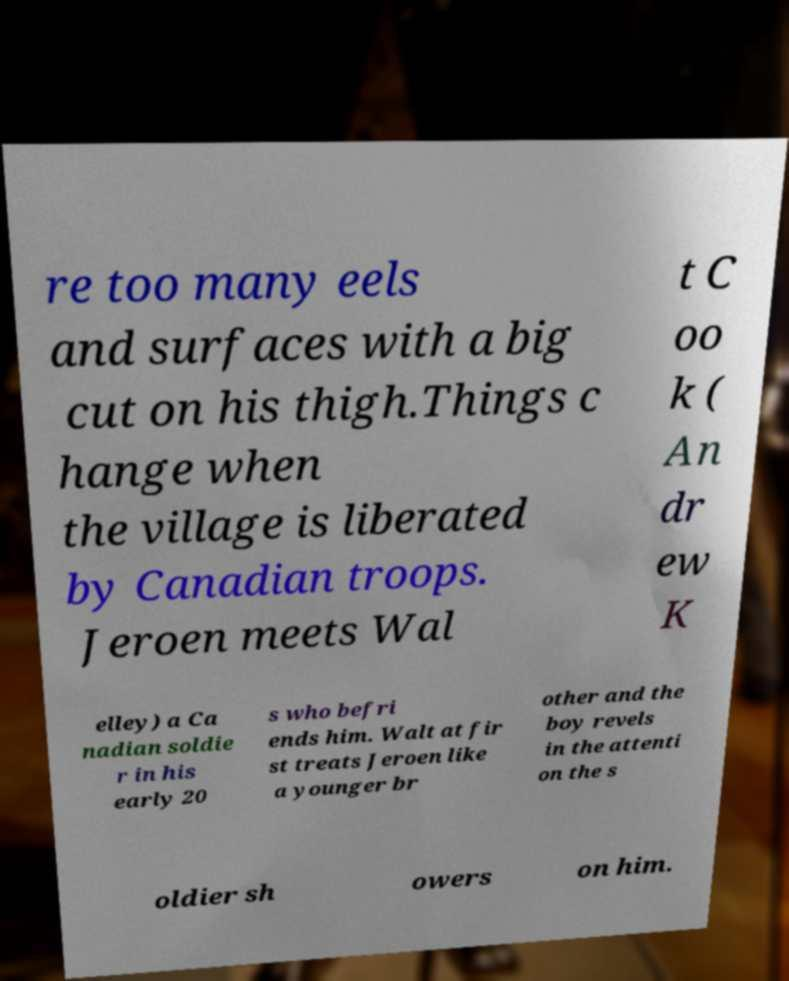Could you assist in decoding the text presented in this image and type it out clearly? re too many eels and surfaces with a big cut on his thigh.Things c hange when the village is liberated by Canadian troops. Jeroen meets Wal t C oo k ( An dr ew K elley) a Ca nadian soldie r in his early 20 s who befri ends him. Walt at fir st treats Jeroen like a younger br other and the boy revels in the attenti on the s oldier sh owers on him. 